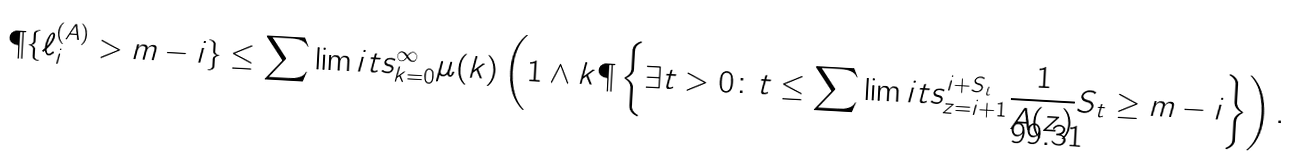<formula> <loc_0><loc_0><loc_500><loc_500>\P \{ \ell ^ { ( A ) } _ { i } > m - i \} \leq \sum \lim i t s _ { k = 0 } ^ { \infty } \mu ( k ) \left ( 1 \wedge k \P \left \{ \exists t > 0 \colon t \leq \sum \lim i t s ^ { i + S _ { t } } _ { z = i + 1 } \frac { 1 } { A ( z ) } S _ { t } \geq m - i \right \} \right ) .</formula> 